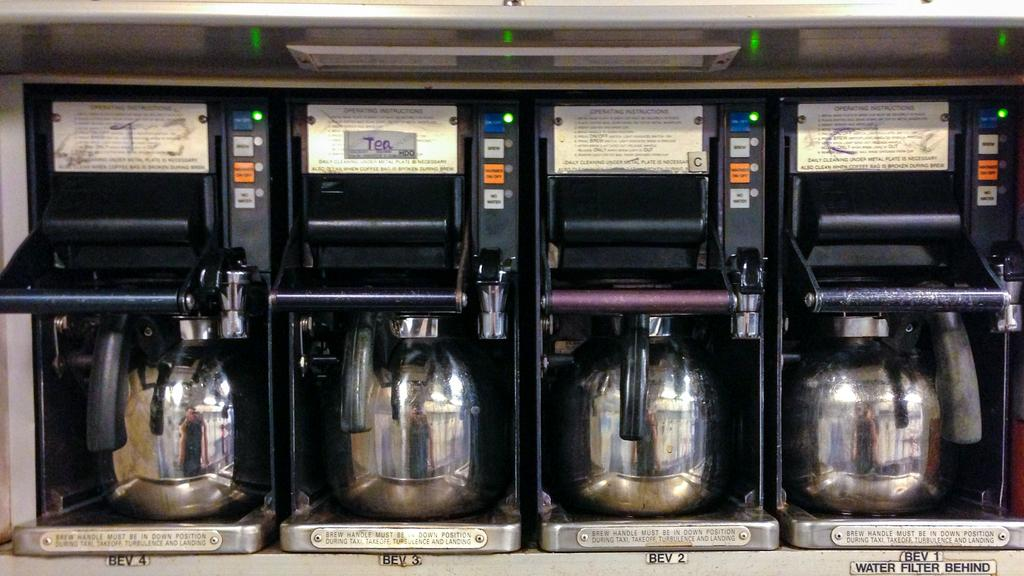<image>
Present a compact description of the photo's key features. Coffee and tea machines are lined up, with one labeled 'tea'. 